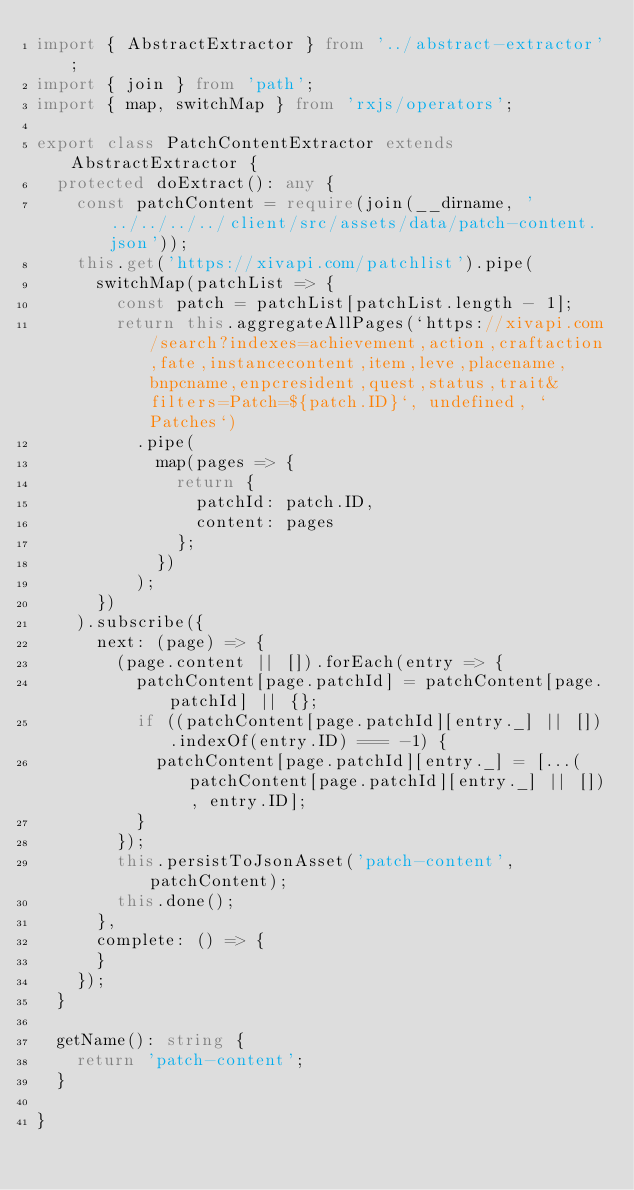Convert code to text. <code><loc_0><loc_0><loc_500><loc_500><_TypeScript_>import { AbstractExtractor } from '../abstract-extractor';
import { join } from 'path';
import { map, switchMap } from 'rxjs/operators';

export class PatchContentExtractor extends AbstractExtractor {
  protected doExtract(): any {
    const patchContent = require(join(__dirname, '../../../../client/src/assets/data/patch-content.json'));
    this.get('https://xivapi.com/patchlist').pipe(
      switchMap(patchList => {
        const patch = patchList[patchList.length - 1];
        return this.aggregateAllPages(`https://xivapi.com/search?indexes=achievement,action,craftaction,fate,instancecontent,item,leve,placename,bnpcname,enpcresident,quest,status,trait&filters=Patch=${patch.ID}`, undefined, `Patches`)
          .pipe(
            map(pages => {
              return {
                patchId: patch.ID,
                content: pages
              };
            })
          );
      })
    ).subscribe({
      next: (page) => {
        (page.content || []).forEach(entry => {
          patchContent[page.patchId] = patchContent[page.patchId] || {};
          if ((patchContent[page.patchId][entry._] || []).indexOf(entry.ID) === -1) {
            patchContent[page.patchId][entry._] = [...(patchContent[page.patchId][entry._] || []), entry.ID];
          }
        });
        this.persistToJsonAsset('patch-content', patchContent);
        this.done();
      },
      complete: () => {
      }
    });
  }

  getName(): string {
    return 'patch-content';
  }

}
</code> 